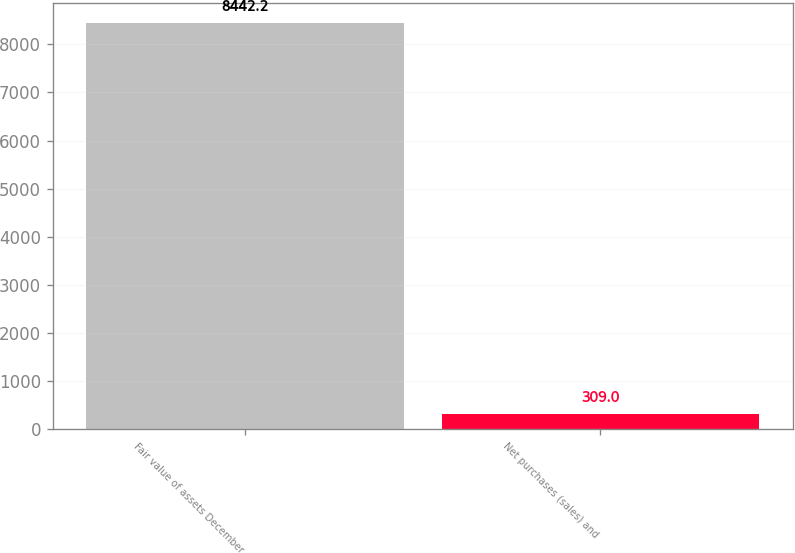Convert chart to OTSL. <chart><loc_0><loc_0><loc_500><loc_500><bar_chart><fcel>Fair value of assets December<fcel>Net purchases (sales) and<nl><fcel>8442.2<fcel>309<nl></chart> 